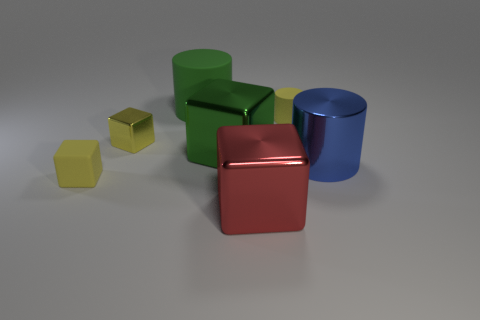Subtract 2 blocks. How many blocks are left? 2 Subtract all large cylinders. How many cylinders are left? 1 Add 3 tiny cyan spheres. How many objects exist? 10 Subtract all brown cubes. Subtract all blue balls. How many cubes are left? 4 Add 4 yellow metallic cubes. How many yellow metallic cubes exist? 5 Subtract 0 red cylinders. How many objects are left? 7 Subtract all cylinders. How many objects are left? 4 Subtract all tiny rubber cylinders. Subtract all yellow shiny things. How many objects are left? 5 Add 5 cylinders. How many cylinders are left? 8 